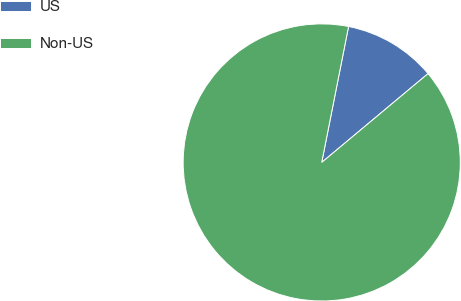Convert chart to OTSL. <chart><loc_0><loc_0><loc_500><loc_500><pie_chart><fcel>US<fcel>Non-US<nl><fcel>10.82%<fcel>89.18%<nl></chart> 